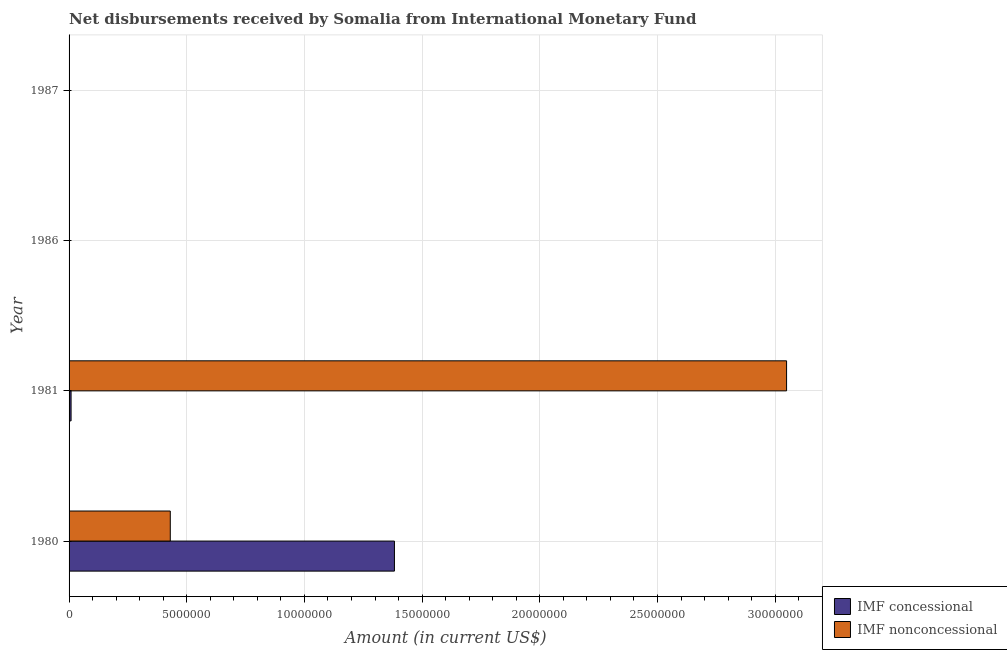Are the number of bars per tick equal to the number of legend labels?
Give a very brief answer. No. How many bars are there on the 1st tick from the top?
Your answer should be very brief. 0. What is the label of the 3rd group of bars from the top?
Your answer should be very brief. 1981. In how many cases, is the number of bars for a given year not equal to the number of legend labels?
Make the answer very short. 2. What is the net non concessional disbursements from imf in 1986?
Keep it short and to the point. 0. Across all years, what is the maximum net concessional disbursements from imf?
Your response must be concise. 1.38e+07. What is the total net concessional disbursements from imf in the graph?
Offer a terse response. 1.39e+07. What is the difference between the net non concessional disbursements from imf in 1980 and that in 1981?
Provide a short and direct response. -2.62e+07. What is the difference between the net concessional disbursements from imf in 1981 and the net non concessional disbursements from imf in 1987?
Your answer should be very brief. 8.50e+04. What is the average net concessional disbursements from imf per year?
Keep it short and to the point. 3.48e+06. In the year 1981, what is the difference between the net concessional disbursements from imf and net non concessional disbursements from imf?
Make the answer very short. -3.04e+07. Is the net non concessional disbursements from imf in 1980 less than that in 1981?
Provide a succinct answer. Yes. What is the difference between the highest and the lowest net non concessional disbursements from imf?
Offer a terse response. 3.05e+07. What is the difference between two consecutive major ticks on the X-axis?
Provide a succinct answer. 5.00e+06. Are the values on the major ticks of X-axis written in scientific E-notation?
Make the answer very short. No. Where does the legend appear in the graph?
Provide a short and direct response. Bottom right. What is the title of the graph?
Your response must be concise. Net disbursements received by Somalia from International Monetary Fund. Does "Food" appear as one of the legend labels in the graph?
Provide a succinct answer. No. What is the label or title of the Y-axis?
Provide a short and direct response. Year. What is the Amount (in current US$) of IMF concessional in 1980?
Keep it short and to the point. 1.38e+07. What is the Amount (in current US$) in IMF nonconcessional in 1980?
Ensure brevity in your answer.  4.30e+06. What is the Amount (in current US$) of IMF concessional in 1981?
Your response must be concise. 8.50e+04. What is the Amount (in current US$) of IMF nonconcessional in 1981?
Offer a terse response. 3.05e+07. What is the Amount (in current US$) in IMF concessional in 1987?
Make the answer very short. 0. What is the Amount (in current US$) of IMF nonconcessional in 1987?
Offer a terse response. 0. Across all years, what is the maximum Amount (in current US$) of IMF concessional?
Your answer should be compact. 1.38e+07. Across all years, what is the maximum Amount (in current US$) in IMF nonconcessional?
Ensure brevity in your answer.  3.05e+07. What is the total Amount (in current US$) in IMF concessional in the graph?
Offer a terse response. 1.39e+07. What is the total Amount (in current US$) of IMF nonconcessional in the graph?
Give a very brief answer. 3.48e+07. What is the difference between the Amount (in current US$) of IMF concessional in 1980 and that in 1981?
Your answer should be very brief. 1.37e+07. What is the difference between the Amount (in current US$) in IMF nonconcessional in 1980 and that in 1981?
Your response must be concise. -2.62e+07. What is the difference between the Amount (in current US$) of IMF concessional in 1980 and the Amount (in current US$) of IMF nonconcessional in 1981?
Make the answer very short. -1.67e+07. What is the average Amount (in current US$) of IMF concessional per year?
Offer a very short reply. 3.48e+06. What is the average Amount (in current US$) of IMF nonconcessional per year?
Provide a succinct answer. 8.70e+06. In the year 1980, what is the difference between the Amount (in current US$) in IMF concessional and Amount (in current US$) in IMF nonconcessional?
Keep it short and to the point. 9.52e+06. In the year 1981, what is the difference between the Amount (in current US$) of IMF concessional and Amount (in current US$) of IMF nonconcessional?
Your response must be concise. -3.04e+07. What is the ratio of the Amount (in current US$) of IMF concessional in 1980 to that in 1981?
Make the answer very short. 162.64. What is the ratio of the Amount (in current US$) in IMF nonconcessional in 1980 to that in 1981?
Provide a short and direct response. 0.14. What is the difference between the highest and the lowest Amount (in current US$) of IMF concessional?
Make the answer very short. 1.38e+07. What is the difference between the highest and the lowest Amount (in current US$) of IMF nonconcessional?
Provide a succinct answer. 3.05e+07. 